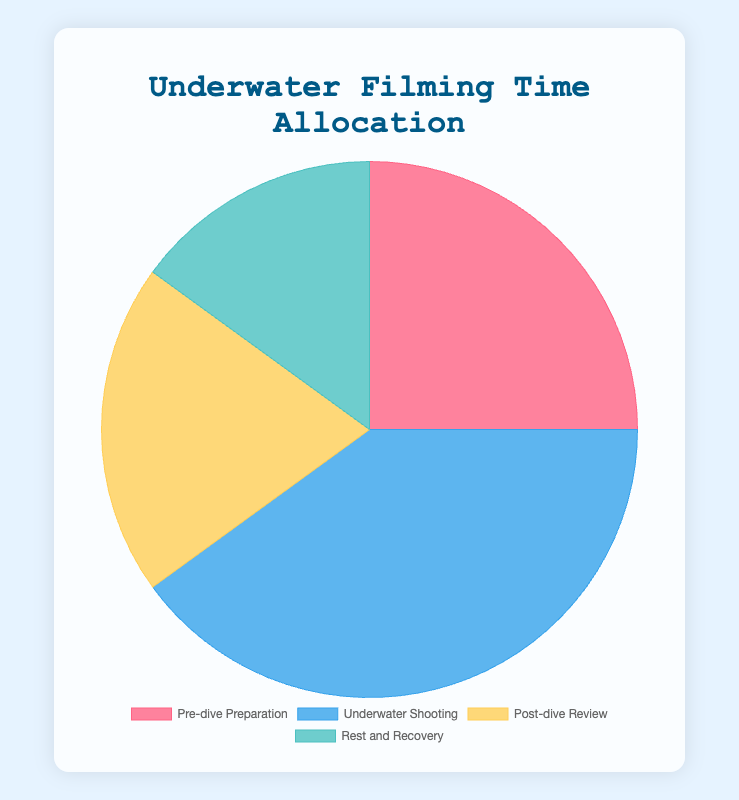What percentage of filming time is allocated to Pre-dive Preparation and Post-dive Review combined? Add the percentage for Pre-dive Preparation (25%) to the percentage for Post-dive Review (20%). 25% + 20% = 45%
Answer: 45% Which task has the largest allocation of filming time? The pie chart shows the allocation for each task, with Underwater Shooting being the largest segment at 40%.
Answer: Underwater Shooting By how many percentage points does Underwater Shooting exceed Pre-dive Preparation? Subtract the percentage for Pre-dive Preparation (25%) from the percentage for Underwater Shooting (40%). 40% - 25% = 15%
Answer: 15% Which color represents Rest and Recovery on the pie chart? The color coding in the legend shows that Rest and Recovery is represented by a green-like color.
Answer: Green How much more time is allocated to Underwater Shooting compared to Rest and Recovery? Subtract the percentage for Rest and Recovery (15%) from Underwater Shooting (40%). 40% - 15% = 25%
Answer: 25% What is the smallest segment in the pie chart and its percentage? The pie chart shows that the smallest segment is Rest and Recovery, which is 15% of the total.
Answer: Rest and Recovery, 15% How does the time allocated for Pre-dive Preparation compare to Post-dive Review? Both percentages are shown in the pie chart: Pre-dive Preparation is 25% and Post-dive Review is 20%. Thus, Pre-dive Preparation is 5% higher.
Answer: Pre-dive Preparation is 5% higher What is the average percentage allocated to each task? Add the percentages of all tasks: 25% + 40% + 20% + 15% = 100%, then divide by the number of tasks, which is 4. 100% ÷ 4 = 25%
Answer: 25% Is the time allocated to Underwater Shooting more than half of the total time? The percentage for Underwater Shooting is 40%, which is less than half of 100%.
Answer: No 